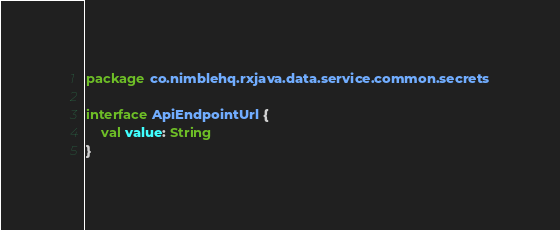<code> <loc_0><loc_0><loc_500><loc_500><_Kotlin_>package co.nimblehq.rxjava.data.service.common.secrets

interface ApiEndpointUrl {
    val value: String
}
</code> 